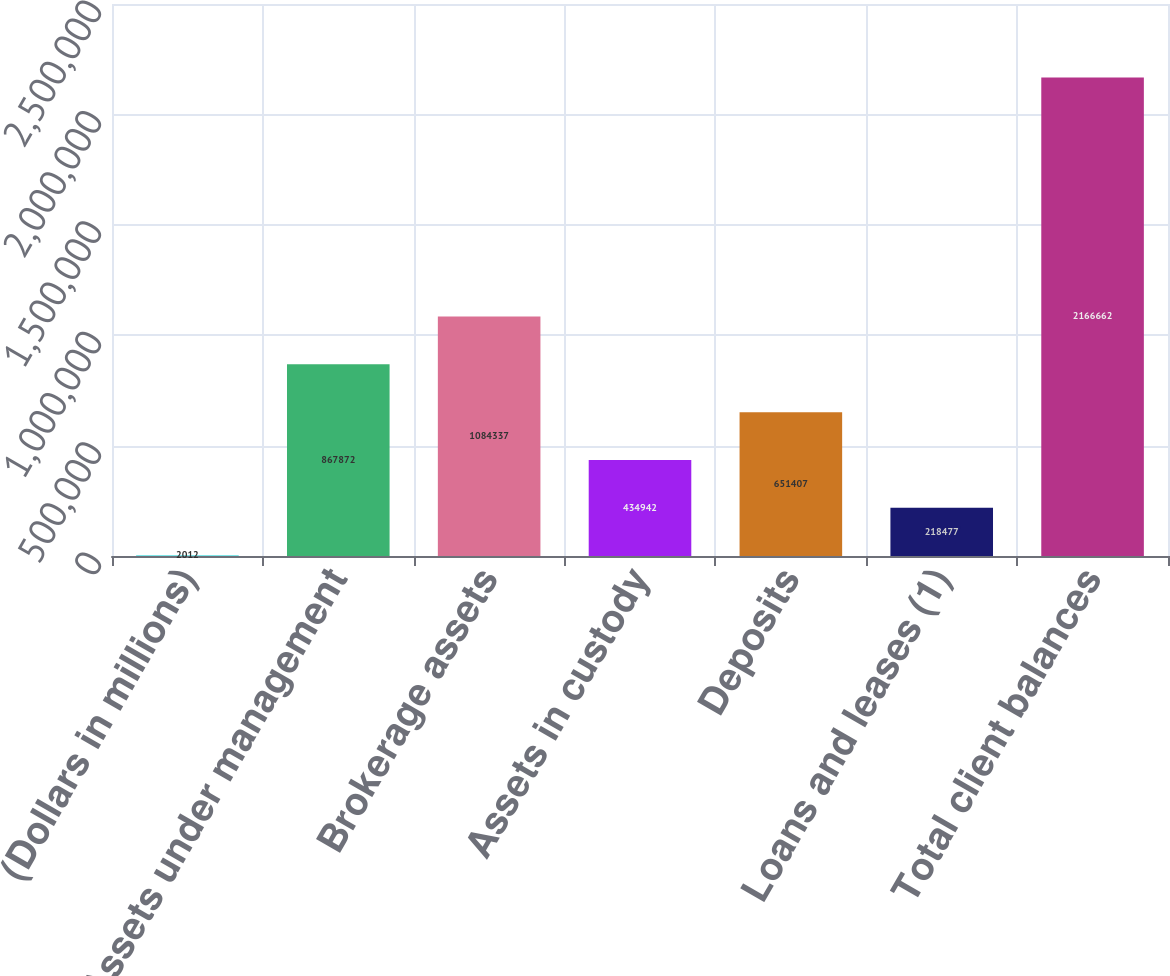Convert chart to OTSL. <chart><loc_0><loc_0><loc_500><loc_500><bar_chart><fcel>(Dollars in millions)<fcel>Assets under management<fcel>Brokerage assets<fcel>Assets in custody<fcel>Deposits<fcel>Loans and leases (1)<fcel>Total client balances<nl><fcel>2012<fcel>867872<fcel>1.08434e+06<fcel>434942<fcel>651407<fcel>218477<fcel>2.16666e+06<nl></chart> 